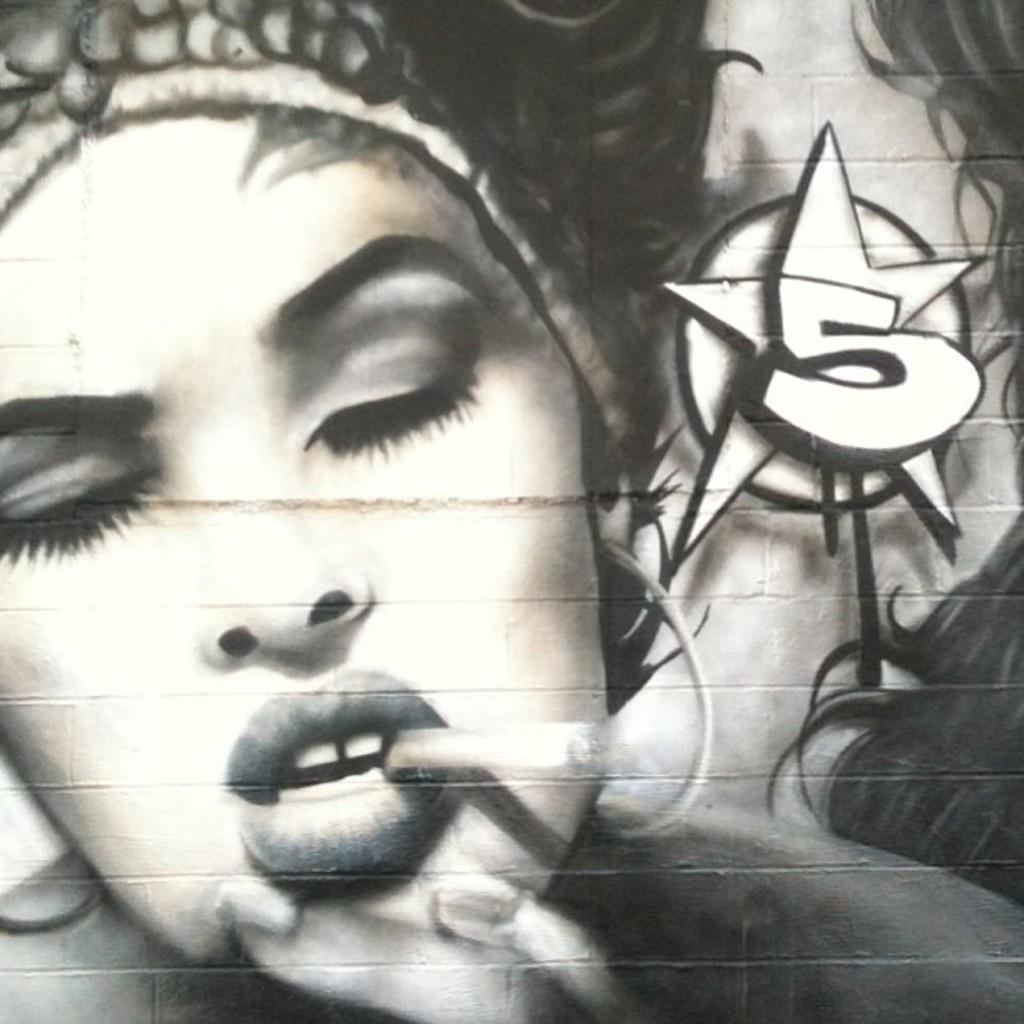What is present on the wall in the image? There is a painting of a woman on the wall. Can you describe the painting on the wall? The painting on the wall features a woman. What type of lettuce is growing out of the woman's vein in the painting? There is no lettuce or vein present in the painting; it is a painting of a woman. What color is the jelly that surrounds the woman in the painting? There is no jelly present in the painting; it is a painting of a woman. 